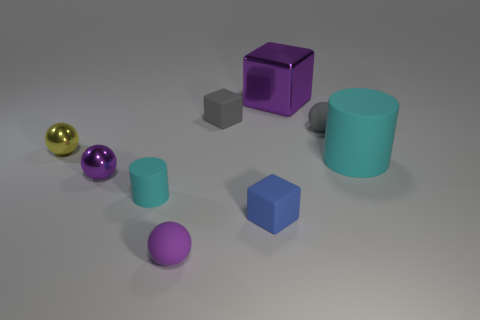What number of metal objects are large cubes or tiny blue blocks?
Offer a terse response. 1. The matte thing that is the same color as the big shiny object is what shape?
Your answer should be very brief. Sphere. What is the material of the purple thing that is behind the large cyan rubber thing?
Make the answer very short. Metal. What number of things are large green rubber cylinders or objects to the right of the tiny blue matte block?
Your answer should be compact. 3. What shape is the purple metal object that is the same size as the gray block?
Your answer should be very brief. Sphere. What number of matte balls are the same color as the small matte cylinder?
Your response must be concise. 0. Is the material of the small ball that is on the right side of the tiny purple matte ball the same as the yellow sphere?
Provide a short and direct response. No. What is the shape of the large purple metal thing?
Your answer should be compact. Cube. What number of purple objects are either big metallic objects or tiny cylinders?
Your answer should be compact. 1. What number of other things are the same material as the gray sphere?
Ensure brevity in your answer.  5. 